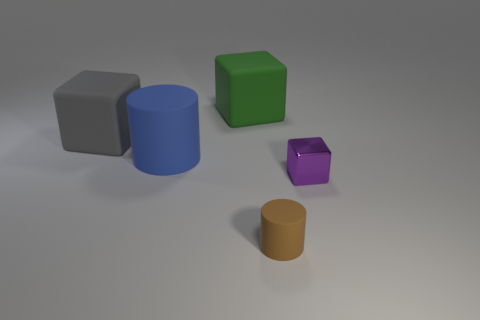Subtract all matte blocks. How many blocks are left? 1 Subtract all gray blocks. How many blocks are left? 2 Subtract all cylinders. How many objects are left? 3 Subtract 2 cubes. How many cubes are left? 1 Add 2 tiny yellow spheres. How many objects exist? 7 Subtract 0 gray spheres. How many objects are left? 5 Subtract all red cylinders. Subtract all yellow blocks. How many cylinders are left? 2 Subtract all green cylinders. How many purple cubes are left? 1 Subtract all gray rubber blocks. Subtract all tiny cyan matte balls. How many objects are left? 4 Add 3 tiny brown cylinders. How many tiny brown cylinders are left? 4 